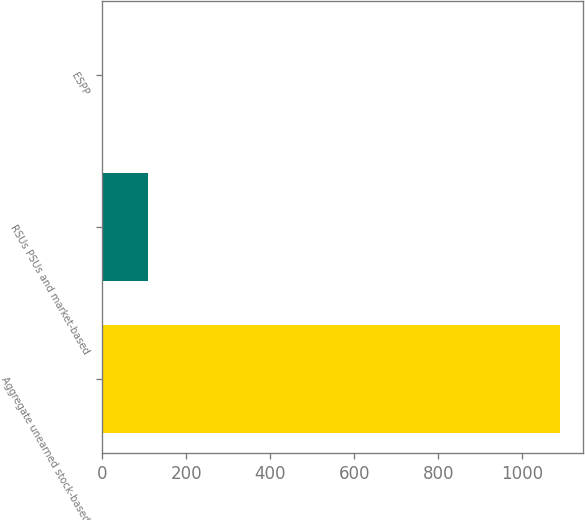Convert chart. <chart><loc_0><loc_0><loc_500><loc_500><bar_chart><fcel>Aggregate unearned stock-based<fcel>RSUs PSUs and market-based<fcel>ESPP<nl><fcel>1091<fcel>109.73<fcel>0.7<nl></chart> 